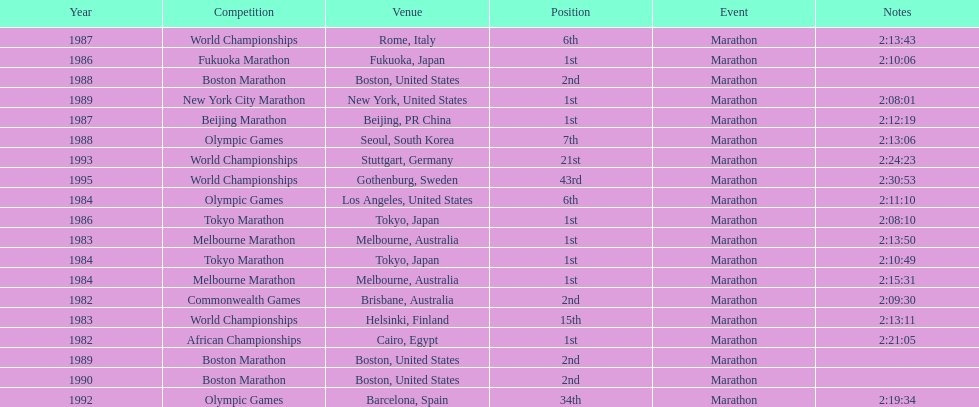Which was the only competition to occur in china? Beijing Marathon. 